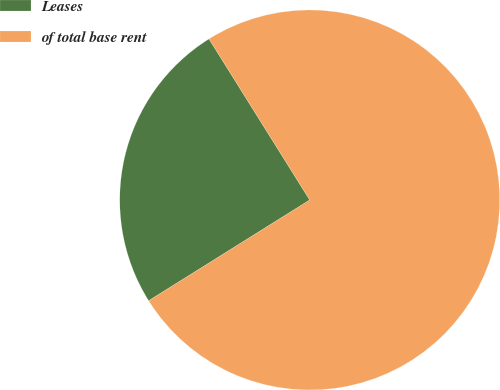Convert chart to OTSL. <chart><loc_0><loc_0><loc_500><loc_500><pie_chart><fcel>Leases<fcel>of total base rent<nl><fcel>25.0%<fcel>75.0%<nl></chart> 